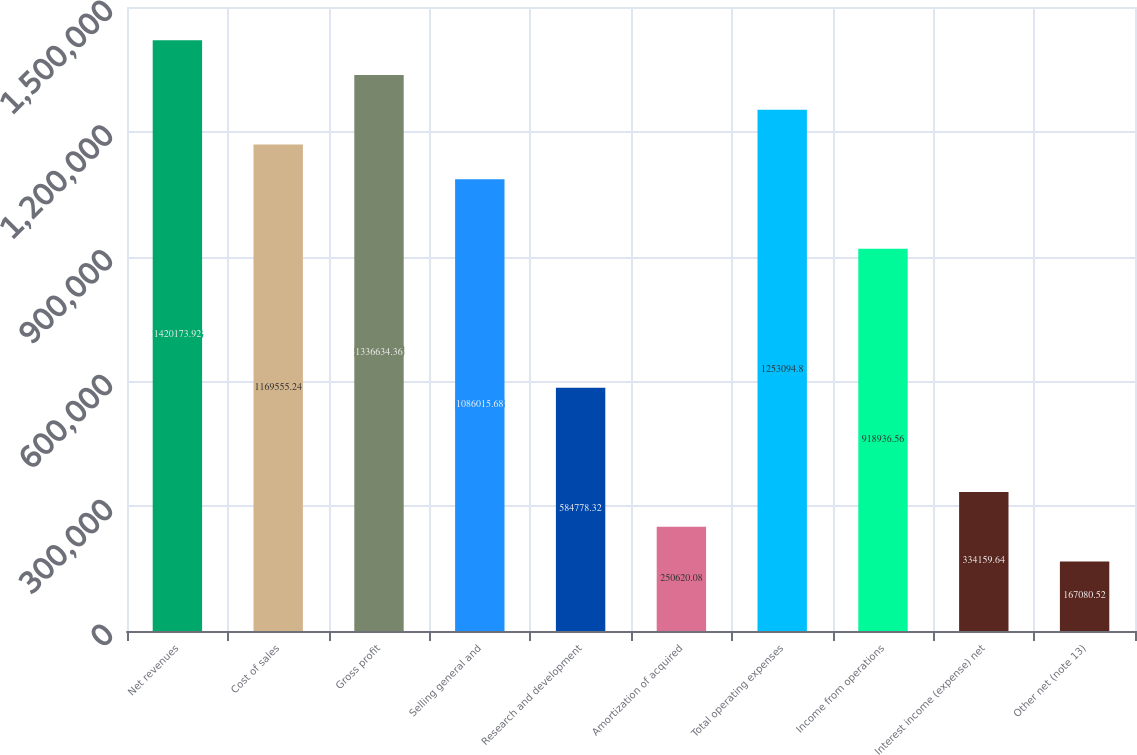Convert chart to OTSL. <chart><loc_0><loc_0><loc_500><loc_500><bar_chart><fcel>Net revenues<fcel>Cost of sales<fcel>Gross profit<fcel>Selling general and<fcel>Research and development<fcel>Amortization of acquired<fcel>Total operating expenses<fcel>Income from operations<fcel>Interest income (expense) net<fcel>Other net (note 13)<nl><fcel>1.42017e+06<fcel>1.16956e+06<fcel>1.33663e+06<fcel>1.08602e+06<fcel>584778<fcel>250620<fcel>1.25309e+06<fcel>918937<fcel>334160<fcel>167081<nl></chart> 